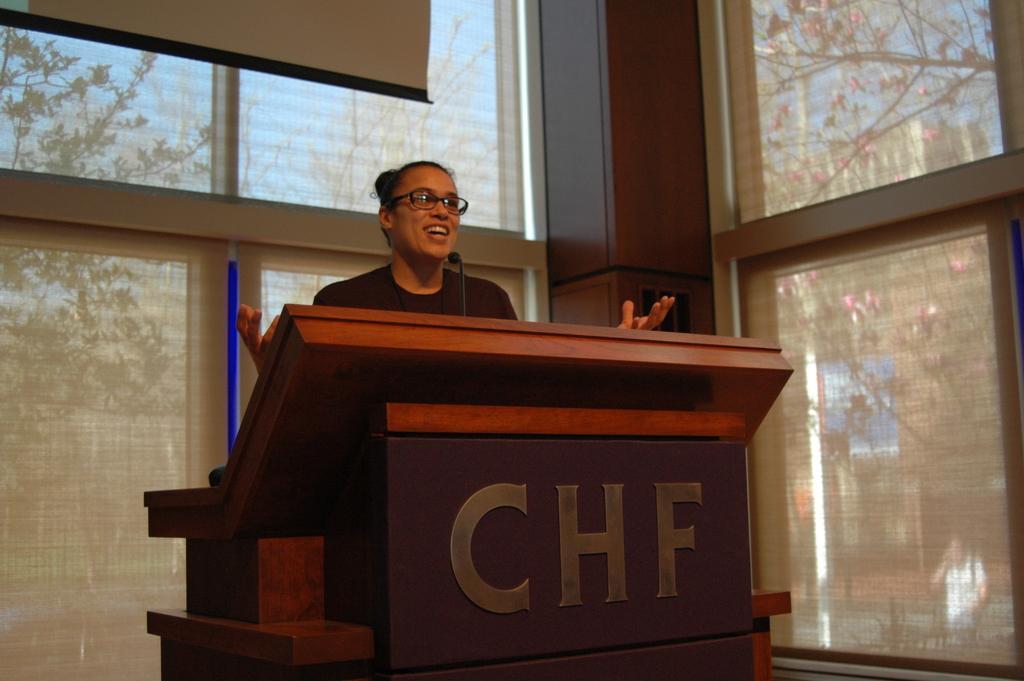How would you summarize this image in a sentence or two? In this image I can see the person is standing in front of the podium. I can see the mic, few windows, trees and the sky. 